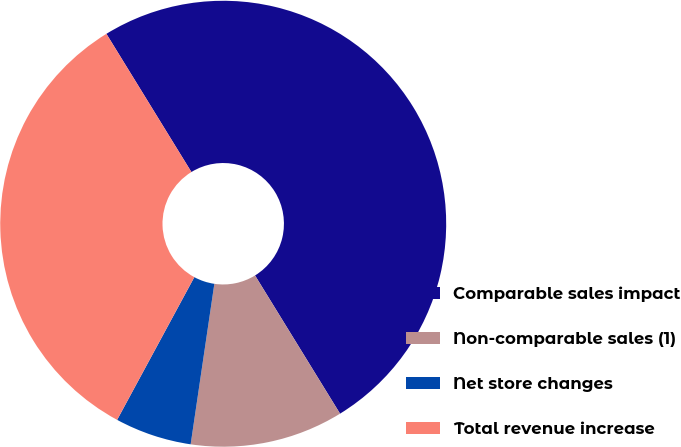Convert chart. <chart><loc_0><loc_0><loc_500><loc_500><pie_chart><fcel>Comparable sales impact<fcel>Non-comparable sales (1)<fcel>Net store changes<fcel>Total revenue increase<nl><fcel>50.0%<fcel>11.11%<fcel>5.56%<fcel>33.33%<nl></chart> 